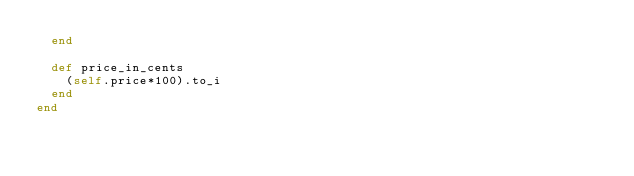<code> <loc_0><loc_0><loc_500><loc_500><_Ruby_>  end

  def price_in_cents
    (self.price*100).to_i
  end
end
</code> 